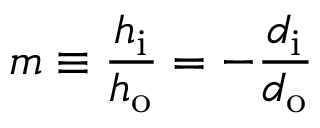Convert formula to latex. <formula><loc_0><loc_0><loc_500><loc_500>m \equiv \frac { h _ { i } } { h _ { o } } = - { \frac { d _ { i } } { d _ { o } } }</formula> 